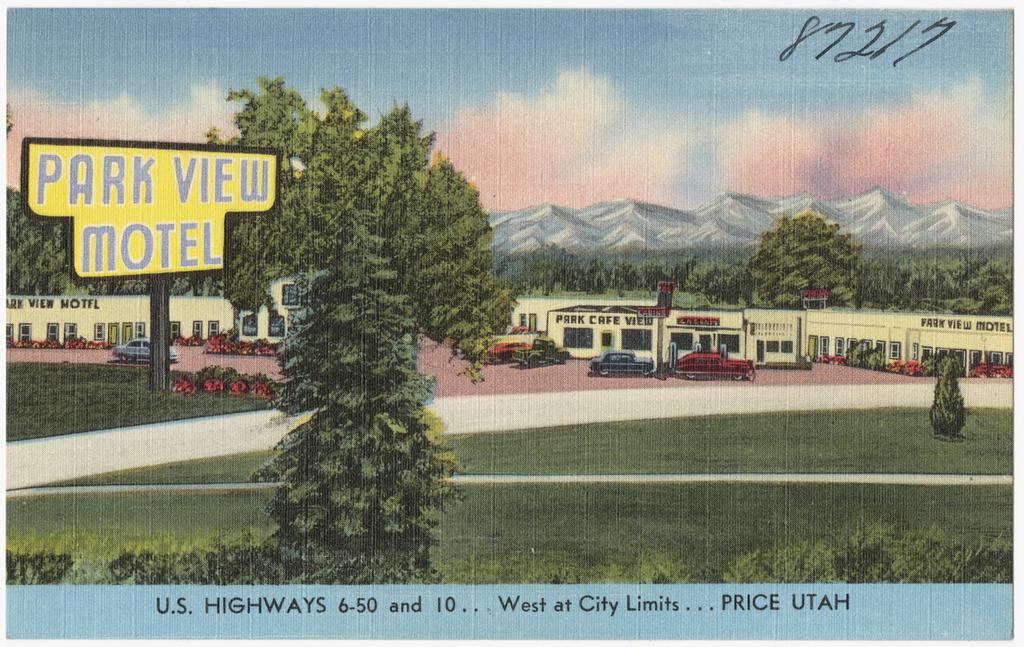What type of natural elements are present in the painting? The painting contains trees, mountains, and grass on the ground. What type of man-made structures are present in the painting? The painting contains buildings and a pole. What type of vehicles are present in the painting? The painting contains cars. What is the condition of the sky in the painting? The sky in the painting is cloudy. Is there any text visible in the painting? Yes, there is a board with text in the painting. What type of zinc is used to create the texture of the mountains in the painting? There is no mention of zinc being used in the painting; it is a visual representation of mountains, trees, cars, buildings, grass, a pole, and a board with text. How many quarters can be seen on the ground in the painting? There are no quarters present in the painting; it features a landscape with trees, mountains, cars, buildings, grass, a pole, and a board with text. 